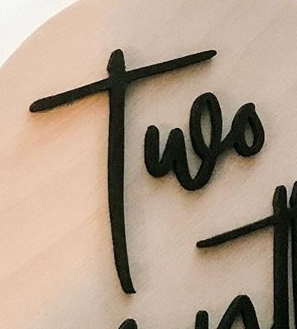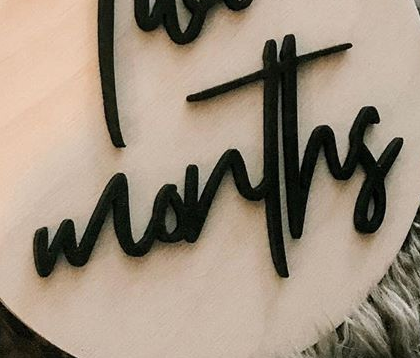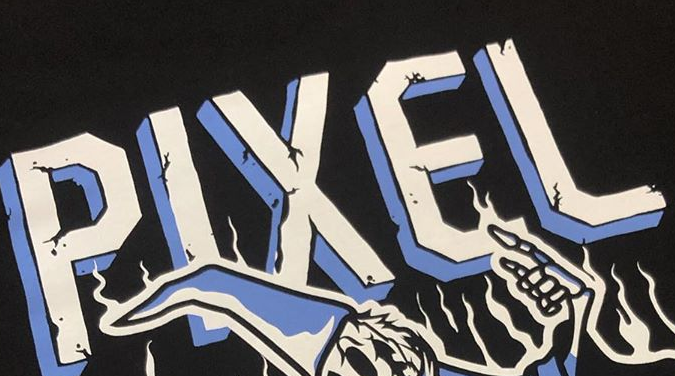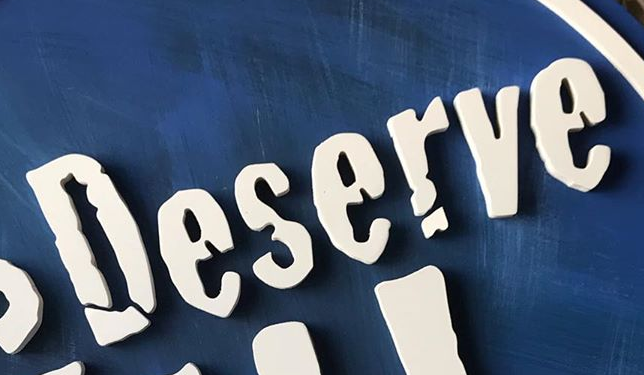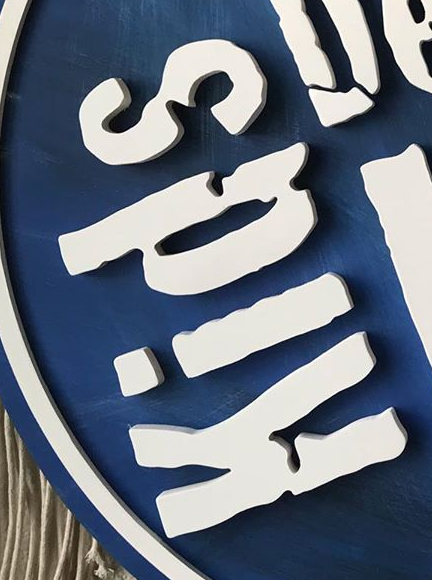What text appears in these images from left to right, separated by a semicolon? Two; months; PIXEL; Deserve; Kids 